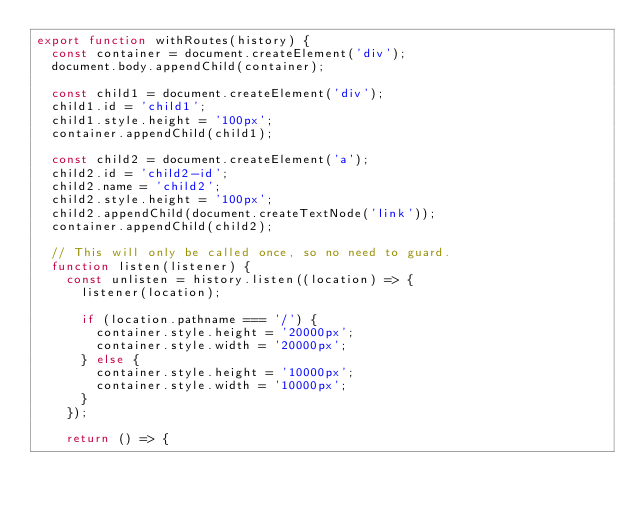Convert code to text. <code><loc_0><loc_0><loc_500><loc_500><_JavaScript_>export function withRoutes(history) {
  const container = document.createElement('div');
  document.body.appendChild(container);

  const child1 = document.createElement('div');
  child1.id = 'child1';
  child1.style.height = '100px';
  container.appendChild(child1);

  const child2 = document.createElement('a');
  child2.id = 'child2-id';
  child2.name = 'child2';
  child2.style.height = '100px';
  child2.appendChild(document.createTextNode('link'));
  container.appendChild(child2);

  // This will only be called once, so no need to guard.
  function listen(listener) {
    const unlisten = history.listen((location) => {
      listener(location);

      if (location.pathname === '/') {
        container.style.height = '20000px';
        container.style.width = '20000px';
      } else {
        container.style.height = '10000px';
        container.style.width = '10000px';
      }
    });

    return () => {</code> 